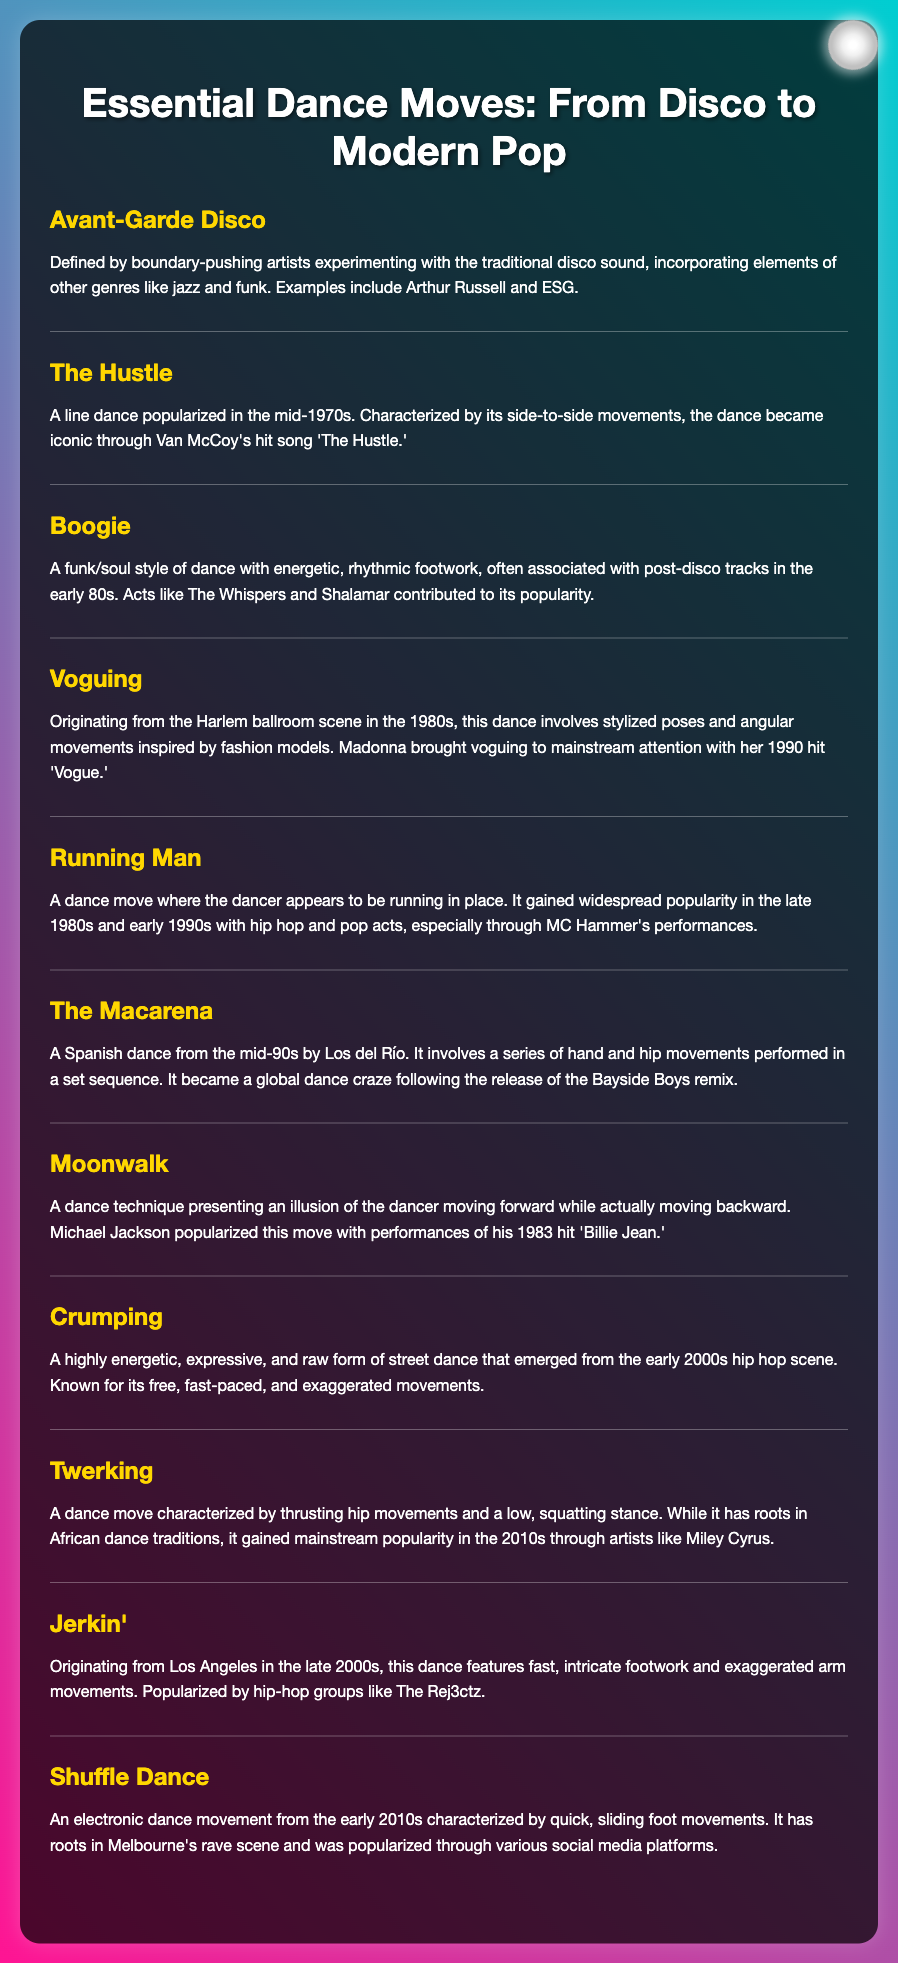What is the first dance move listed? The first dance move in the glossary is "Avant-Garde Disco."
Answer: Avant-Garde Disco Who popularized The Hustle? The Hustle was popularized through Van McCoy's hit song 'The Hustle.'
Answer: Van McCoy Which dance move involves a series of hand and hip movements? The Macarena involves a series of hand and hip movements performed in a set sequence.
Answer: The Macarena What decade did Voguing originate? Voguing originated from the Harlem ballroom scene in the 1980s.
Answer: 1980s What is the primary characteristic of Twerking? Twerking is characterized by thrusting hip movements and a low, squatting stance.
Answer: Thrusting hip movements Which dance is known for appearing to run in place? The dance known for appearing to run in place is the Running Man.
Answer: Running Man What is the dance technique that creates the illusion of moving forward while moving backward? The dance technique that creates this illusion is the Moonwalk.
Answer: Moonwalk What genre influenced the Boogie dance style? The Boogie dance style is influenced by funk/soul music.
Answer: Funk/Soul What is the primary style of the Shuffle Dance? The Shuffle Dance is characterized by quick, sliding foot movements.
Answer: Quick, sliding foot movements 